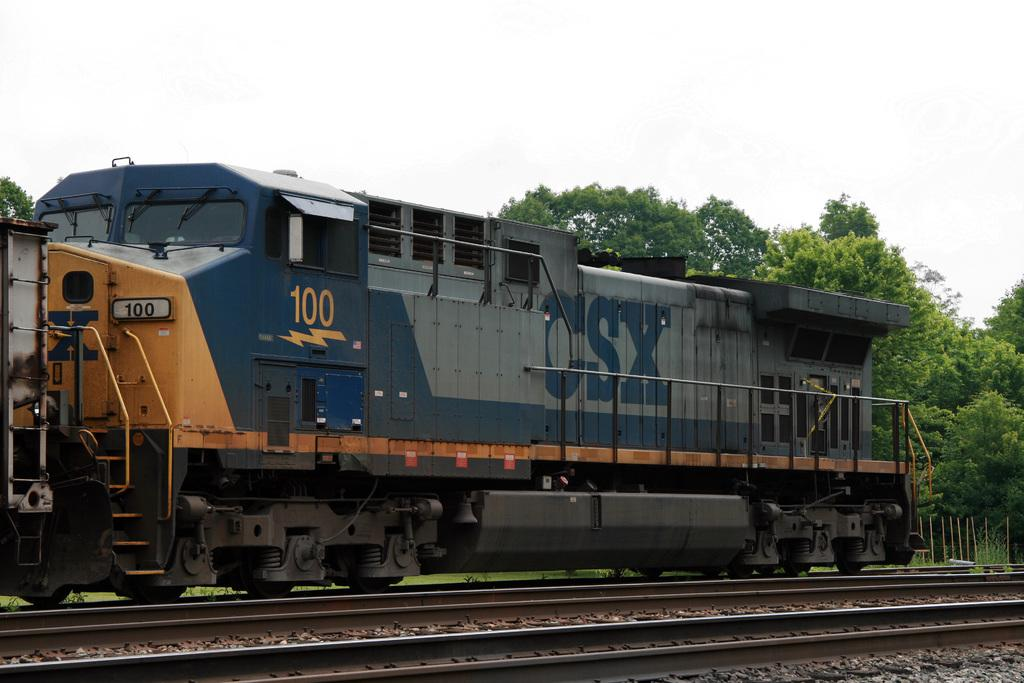What is the main subject of the image? The main subject of the image is a train. What is the train situated on in the image? The train is situated on a railway track in the image. What type of natural vegetation is visible in the image? There are trees visible in the image. What type of barrier is present in the image? There is a fence present in the image. What is visible in the background of the image? The sky is visible in the image. What type of caption can be seen on the train in the image? There is no caption visible on the train in the image. What type of leather material is used to cover the sink in the image? There is no sink or leather material present in the image. 